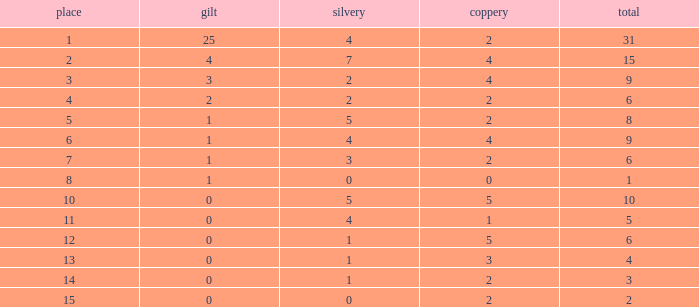What is the highest rank of the medal total less than 15, more than 2 bronzes, 0 gold and 1 silver? 13.0. 